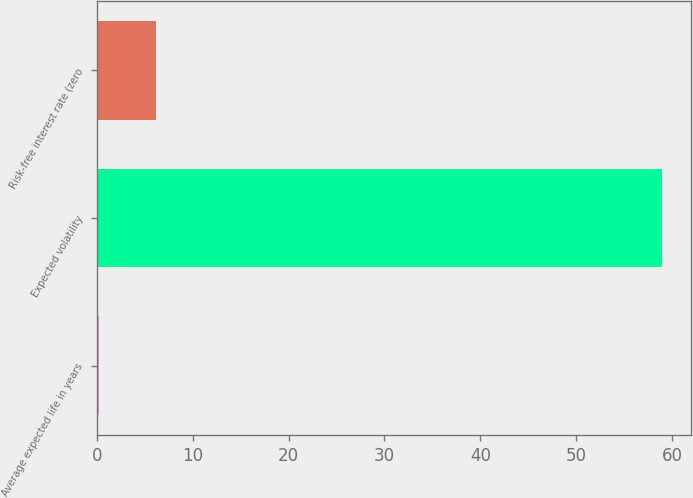Convert chart. <chart><loc_0><loc_0><loc_500><loc_500><bar_chart><fcel>Average expected life in years<fcel>Expected volatility<fcel>Risk-free interest rate (zero<nl><fcel>0.25<fcel>59<fcel>6.12<nl></chart> 